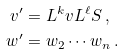Convert formula to latex. <formula><loc_0><loc_0><loc_500><loc_500>v ^ { \prime } & = L ^ { k } v L ^ { \ell } S \, , \\ w ^ { \prime } & = w _ { 2 } \cdots w _ { n } \, .</formula> 